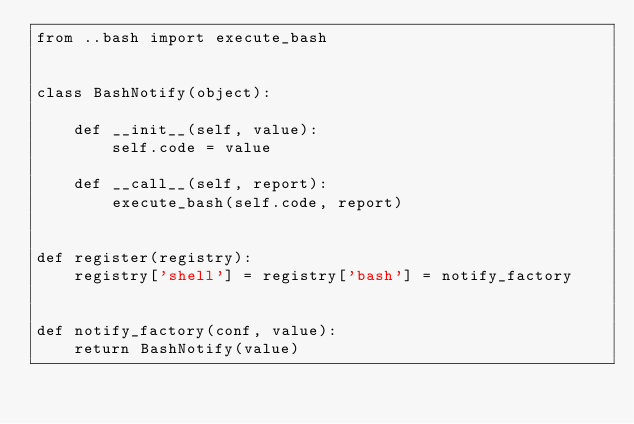Convert code to text. <code><loc_0><loc_0><loc_500><loc_500><_Python_>from ..bash import execute_bash


class BashNotify(object):

    def __init__(self, value):
        self.code = value

    def __call__(self, report):
        execute_bash(self.code, report)


def register(registry):
    registry['shell'] = registry['bash'] = notify_factory


def notify_factory(conf, value):
    return BashNotify(value)
</code> 